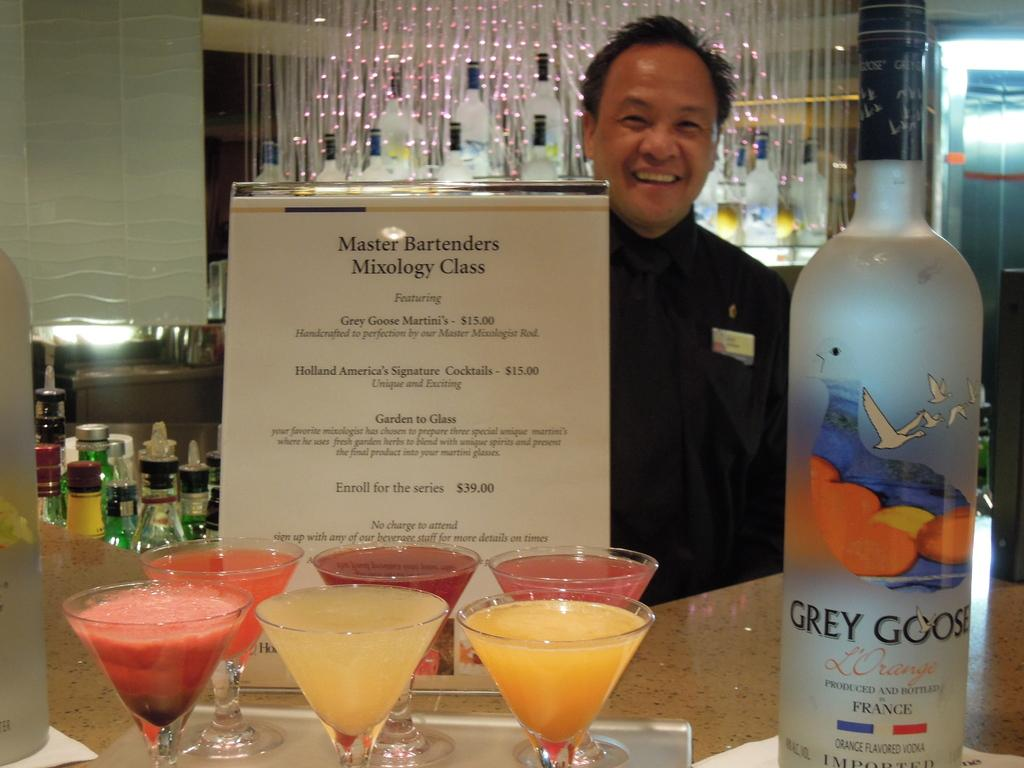<image>
Give a short and clear explanation of the subsequent image. A man poses behind a sign advertising a mixology class. 